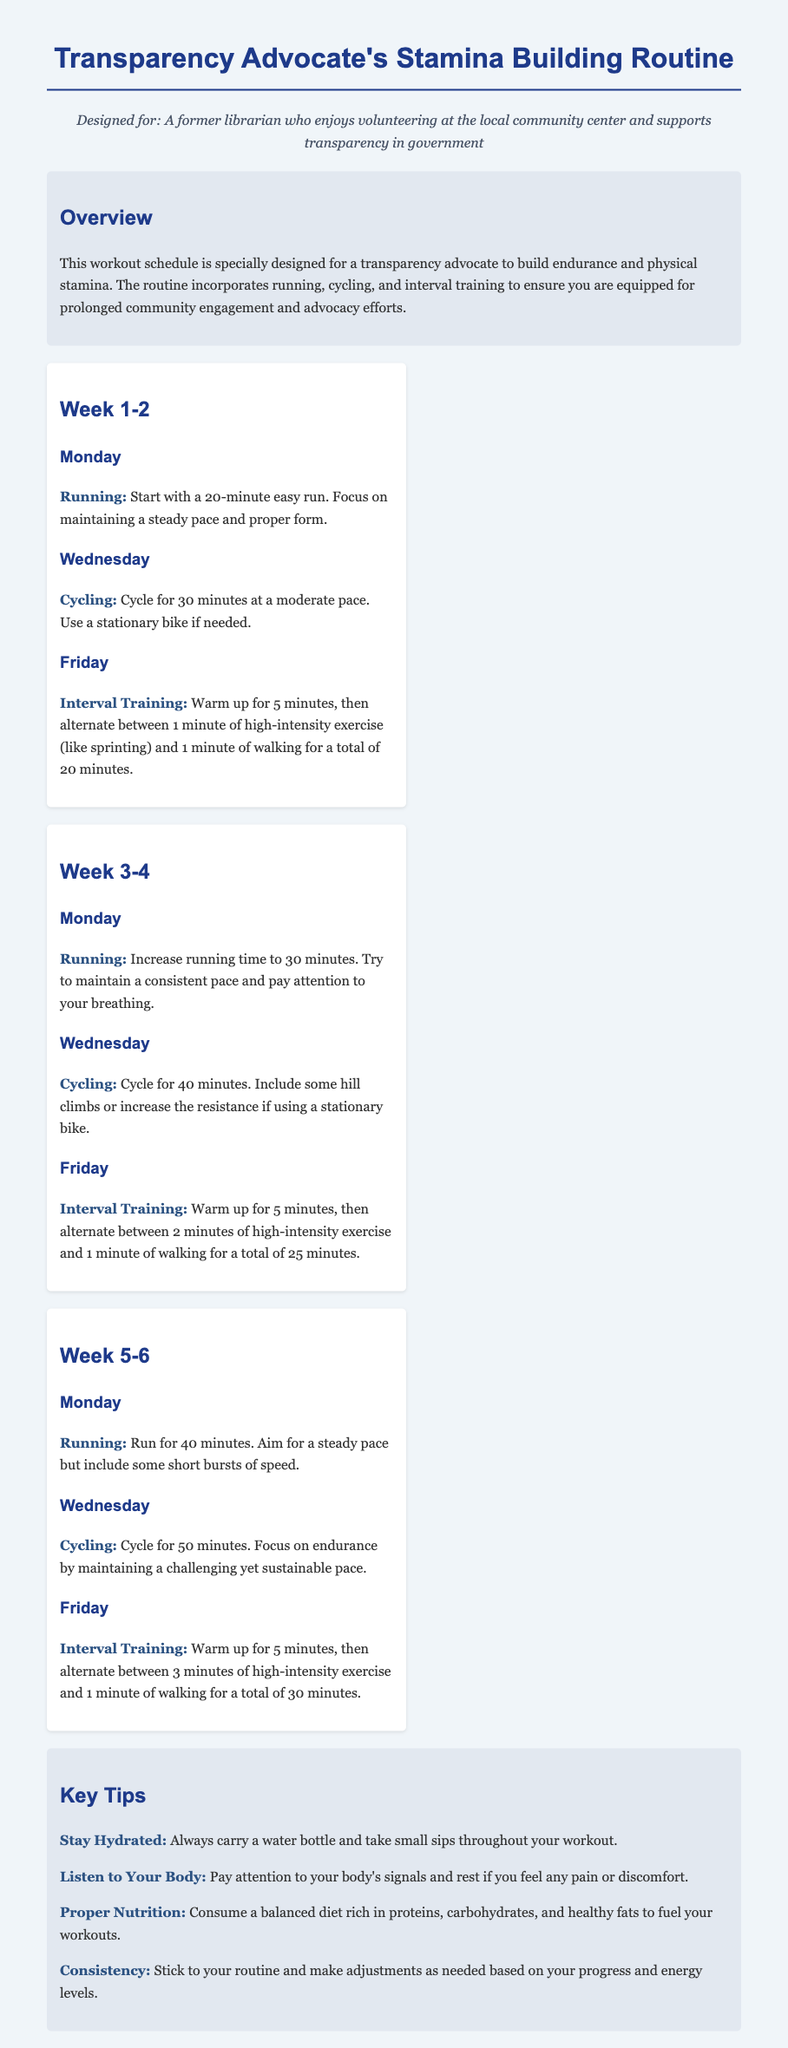What is the primary purpose of the workout schedule? The workout schedule is designed to build endurance and physical stamina for transparency advocates engaging in community work.
Answer: Build endurance and physical stamina How long should the initial running session be? The initial running session in Week 1 is specified to last for 20 minutes.
Answer: 20 minutes What day is designated for Interval Training in Week 3-4? Interval Training is scheduled for Fridays during Week 3-4.
Answer: Friday What is the total duration for cycling in Week 5? In Week 5, the cycling duration is specified to be 50 minutes.
Answer: 50 minutes How many minutes of warm-up are suggested before Interval Training? The document suggests a warm-up duration of 5 minutes before starting Interval Training.
Answer: 5 minutes Which type of exercise is included on Mondays of Weeks 1-2? The exercise included on Mondays of Weeks 1-2 is Running.
Answer: Running What key tip emphasizes hydration? The key tip highlighted regarding hydration is "Stay Hydrated."
Answer: Stay Hydrated In which week does the running time increase to 30 minutes? The running time increases to 30 minutes in Week 3-4.
Answer: Week 3-4 What does the workout plan primarily combine for stamina building? The workout plan combines running, cycling, and interval training for stamina building.
Answer: Running, cycling, and interval training 